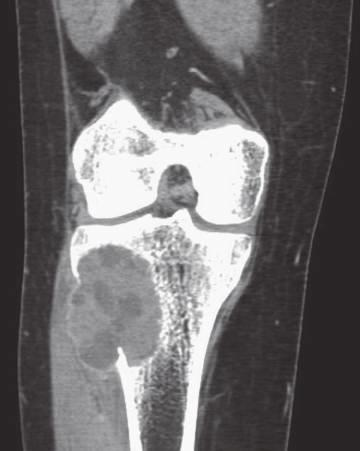what is delineated by a thin rim of reactive subperiosteal bone?
Answer the question using a single word or phrase. The soft tissue component 